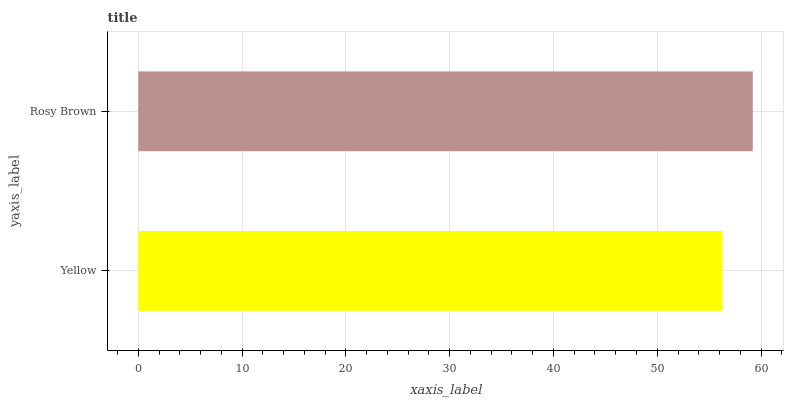Is Yellow the minimum?
Answer yes or no. Yes. Is Rosy Brown the maximum?
Answer yes or no. Yes. Is Rosy Brown the minimum?
Answer yes or no. No. Is Rosy Brown greater than Yellow?
Answer yes or no. Yes. Is Yellow less than Rosy Brown?
Answer yes or no. Yes. Is Yellow greater than Rosy Brown?
Answer yes or no. No. Is Rosy Brown less than Yellow?
Answer yes or no. No. Is Rosy Brown the high median?
Answer yes or no. Yes. Is Yellow the low median?
Answer yes or no. Yes. Is Yellow the high median?
Answer yes or no. No. Is Rosy Brown the low median?
Answer yes or no. No. 